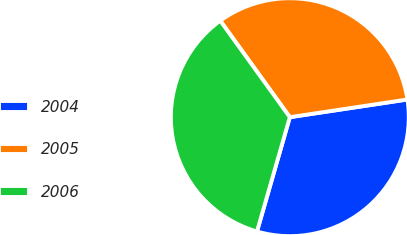Convert chart. <chart><loc_0><loc_0><loc_500><loc_500><pie_chart><fcel>2004<fcel>2005<fcel>2006<nl><fcel>31.83%<fcel>32.57%<fcel>35.6%<nl></chart> 